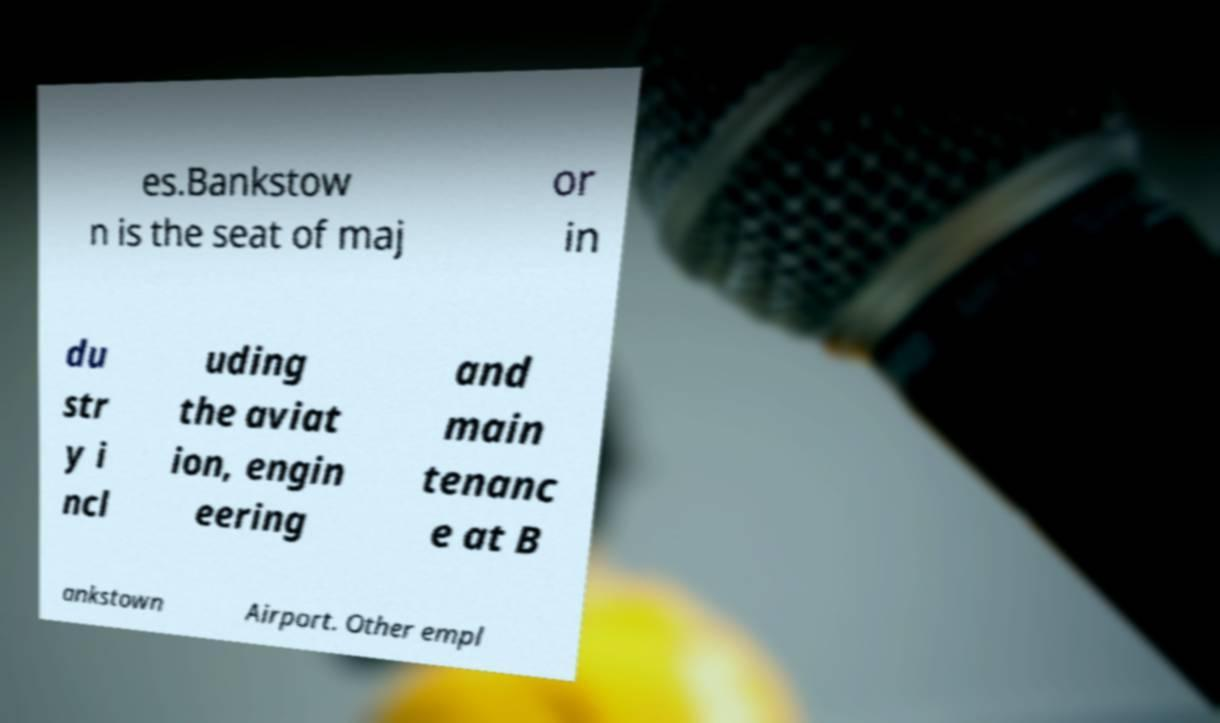Could you extract and type out the text from this image? es.Bankstow n is the seat of maj or in du str y i ncl uding the aviat ion, engin eering and main tenanc e at B ankstown Airport. Other empl 